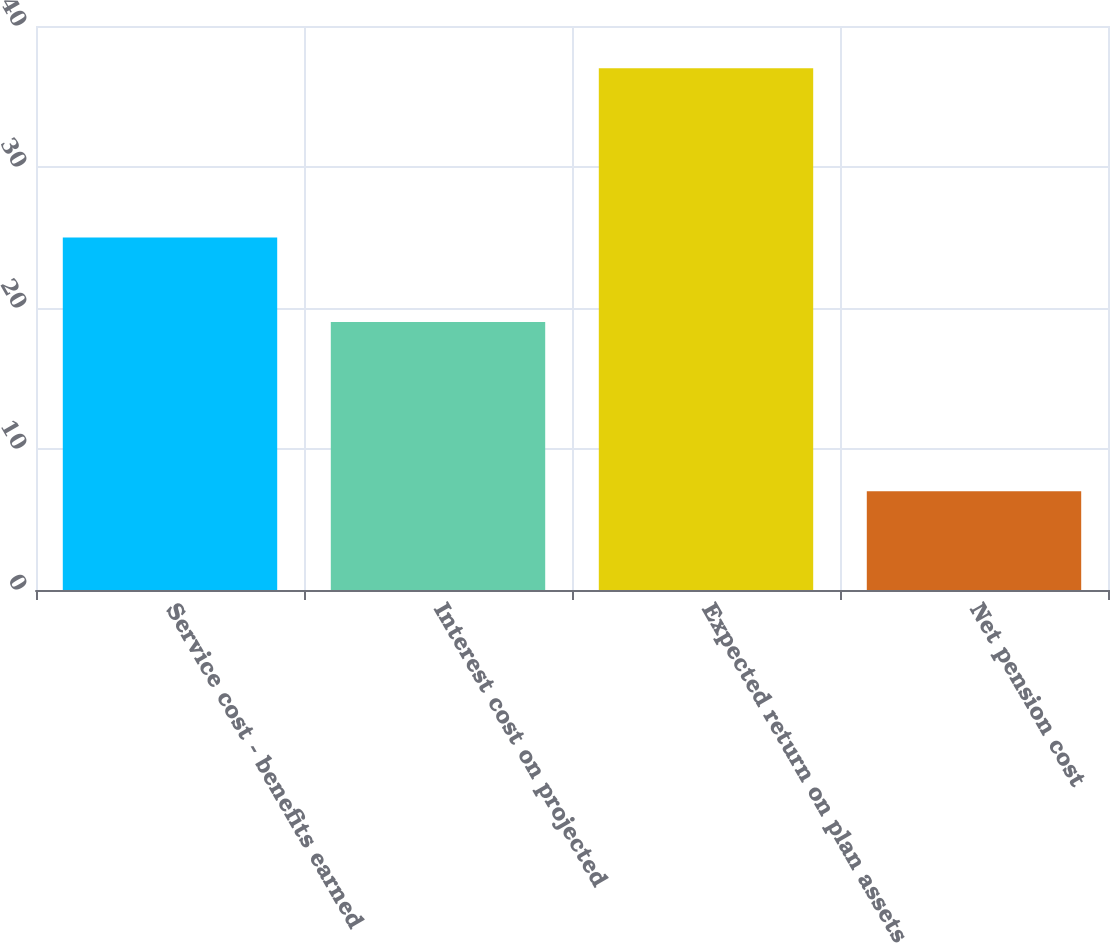Convert chart. <chart><loc_0><loc_0><loc_500><loc_500><bar_chart><fcel>Service cost - benefits earned<fcel>Interest cost on projected<fcel>Expected return on plan assets<fcel>Net pension cost<nl><fcel>25<fcel>19<fcel>37<fcel>7<nl></chart> 